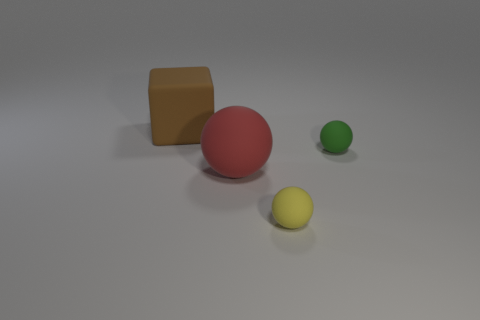Add 4 small green shiny blocks. How many objects exist? 8 Subtract all cubes. How many objects are left? 3 Add 2 big yellow matte cylinders. How many big yellow matte cylinders exist? 2 Subtract 1 red spheres. How many objects are left? 3 Subtract all large things. Subtract all big red balls. How many objects are left? 1 Add 2 yellow matte things. How many yellow matte things are left? 3 